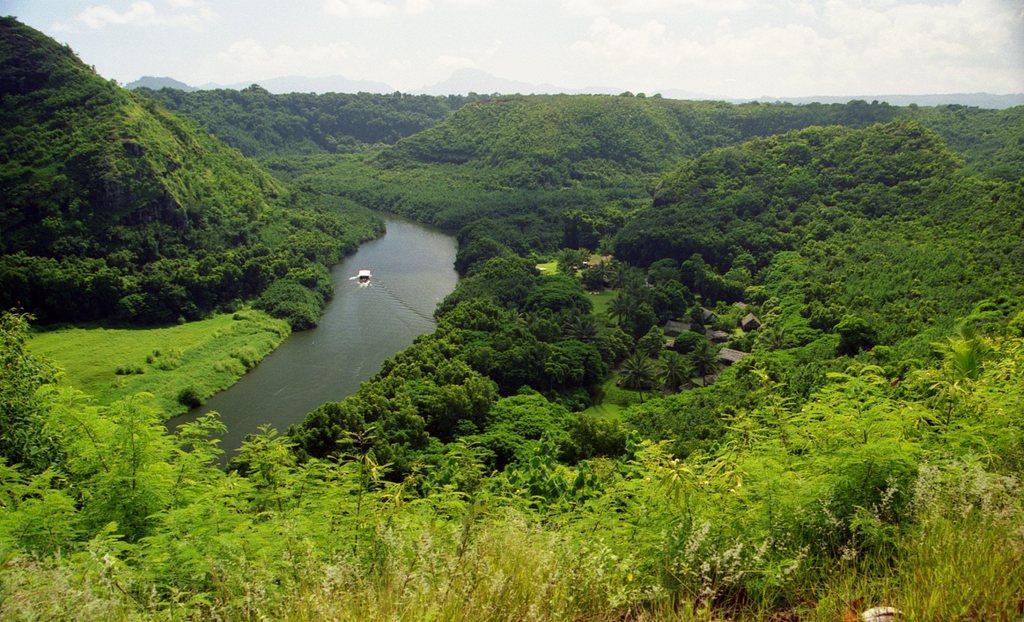In one or two sentences, can you explain what this image depicts? In this image it seems like a lake which is in the middle. In the lake there is a boat. There are hills on either side of the lake. At the bottom there are plants. In the background there are trees on the hills. At the top there is the sky. 